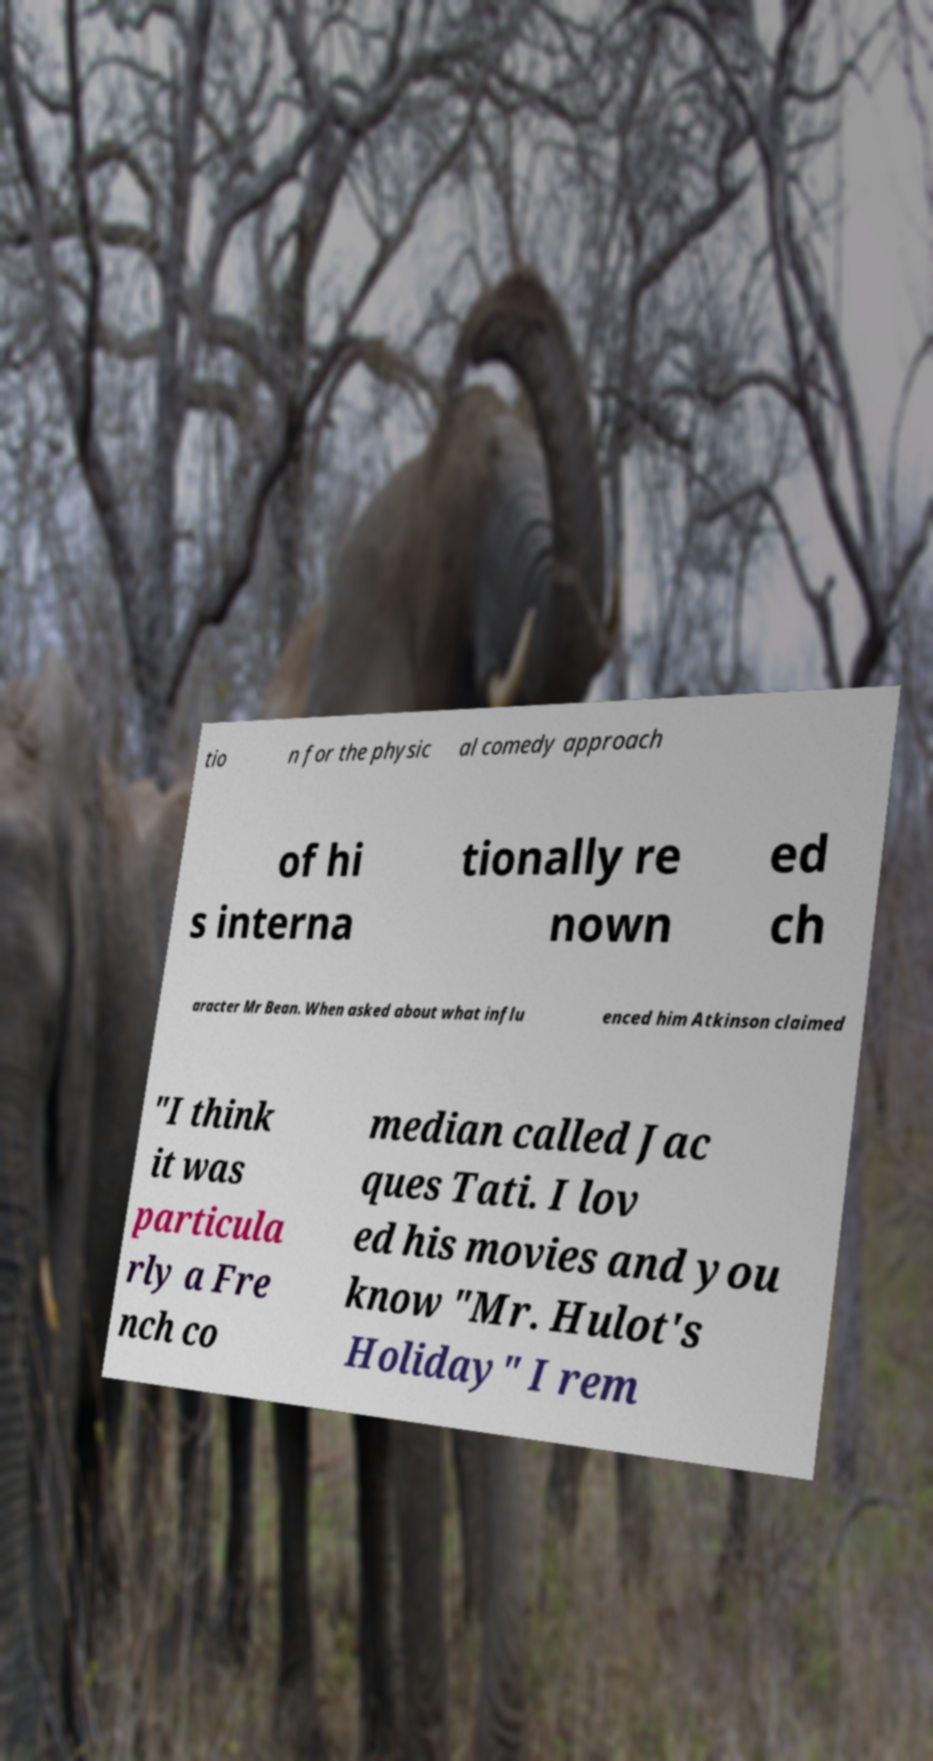I need the written content from this picture converted into text. Can you do that? tio n for the physic al comedy approach of hi s interna tionally re nown ed ch aracter Mr Bean. When asked about what influ enced him Atkinson claimed "I think it was particula rly a Fre nch co median called Jac ques Tati. I lov ed his movies and you know "Mr. Hulot's Holiday" I rem 